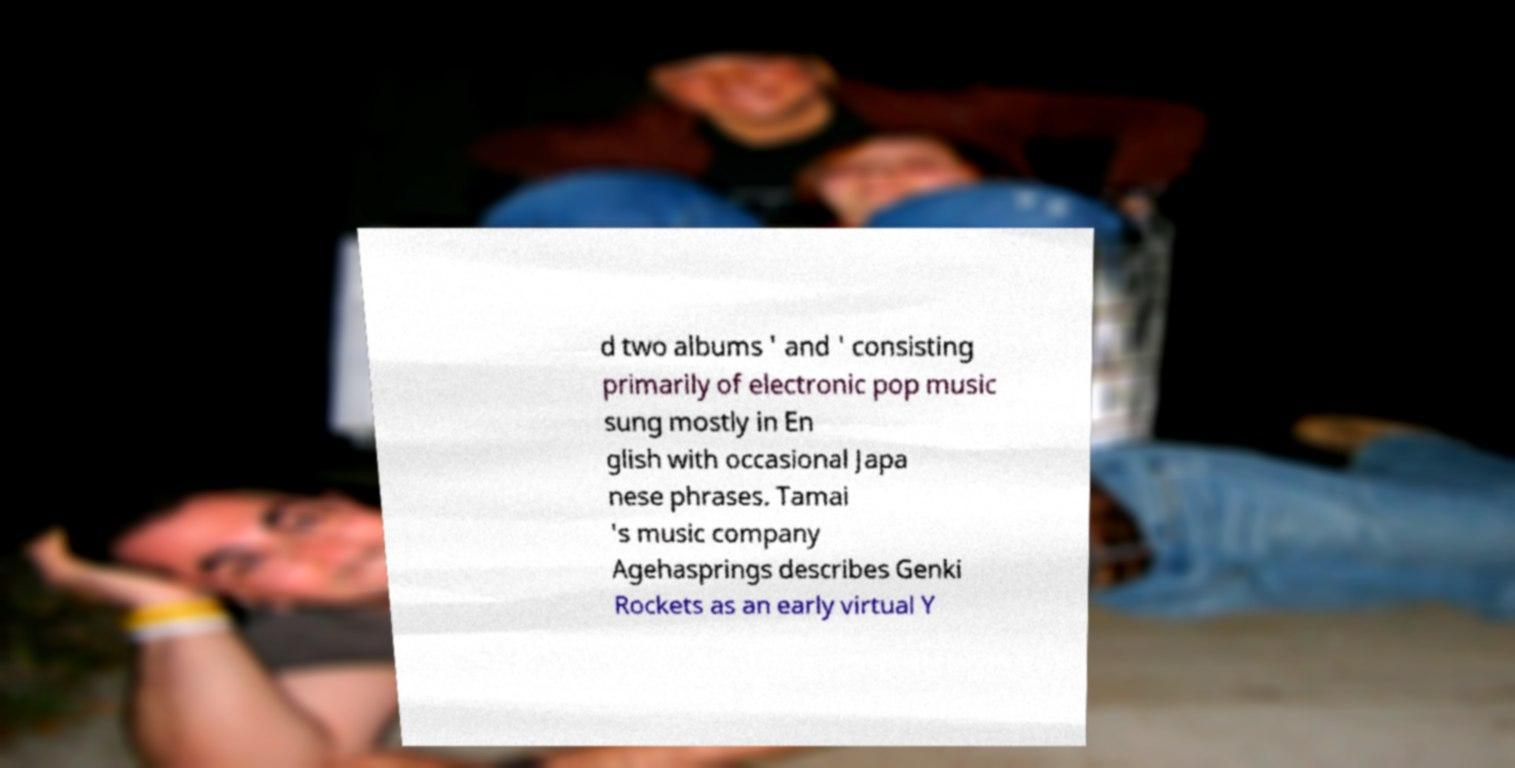I need the written content from this picture converted into text. Can you do that? d two albums ' and ' consisting primarily of electronic pop music sung mostly in En glish with occasional Japa nese phrases. Tamai 's music company Agehasprings describes Genki Rockets as an early virtual Y 